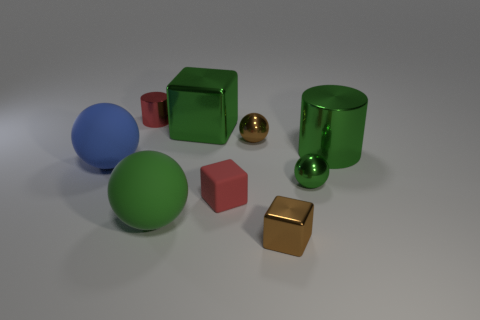There is a blue matte object; does it have the same shape as the big green object left of the large block?
Your answer should be compact. Yes. There is a tiny cube that is the same material as the big cube; what color is it?
Your answer should be very brief. Brown. There is a shiny thing on the left side of the large shiny block; what size is it?
Keep it short and to the point. Small. Does the large block have the same color as the big cylinder?
Your answer should be compact. Yes. Is the number of blue shiny cylinders less than the number of blue spheres?
Your response must be concise. Yes. What color is the metal cylinder that is right of the shiny block behind the large blue thing?
Your answer should be compact. Green. There is a tiny brown object in front of the green thing that is in front of the tiny red object that is in front of the blue sphere; what is its material?
Provide a short and direct response. Metal. Does the cylinder on the right side of the brown metal cube have the same size as the tiny brown block?
Your answer should be compact. No. There is a green ball on the left side of the red block; what is its material?
Keep it short and to the point. Rubber. Are there more blue matte spheres than small red things?
Keep it short and to the point. No. 